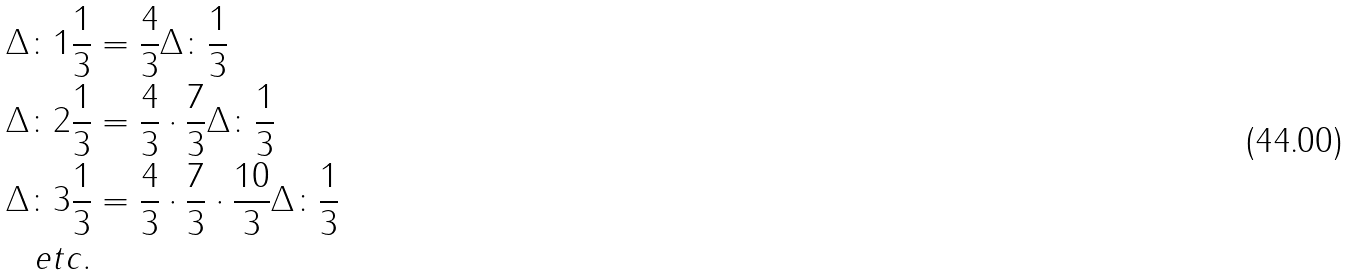<formula> <loc_0><loc_0><loc_500><loc_500>\Delta \colon 1 \frac { 1 } { 3 } & = \frac { 4 } { 3 } \Delta \colon \frac { 1 } { 3 } \\ \Delta \colon 2 \frac { 1 } { 3 } & = \frac { 4 } { 3 } \cdot \frac { 7 } { 3 } \Delta \colon \frac { 1 } { 3 } \\ \Delta \colon 3 \frac { 1 } { 3 } & = \frac { 4 } { 3 } \cdot \frac { 7 } { 3 } \cdot \frac { 1 0 } { 3 } \Delta \colon \frac { 1 } { 3 } \\ e t c . &</formula> 